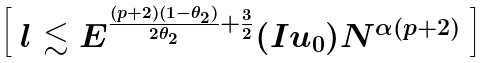Convert formula to latex. <formula><loc_0><loc_0><loc_500><loc_500>\left [ \begin{array} { l } l \lesssim E ^ { \frac { ( p + 2 ) ( 1 - \theta _ { 2 } ) } { 2 \theta _ { 2 } } + \frac { 3 } { 2 } } ( I u _ { 0 } ) N ^ { \alpha ( p + 2 ) } \end{array} \right ]</formula> 